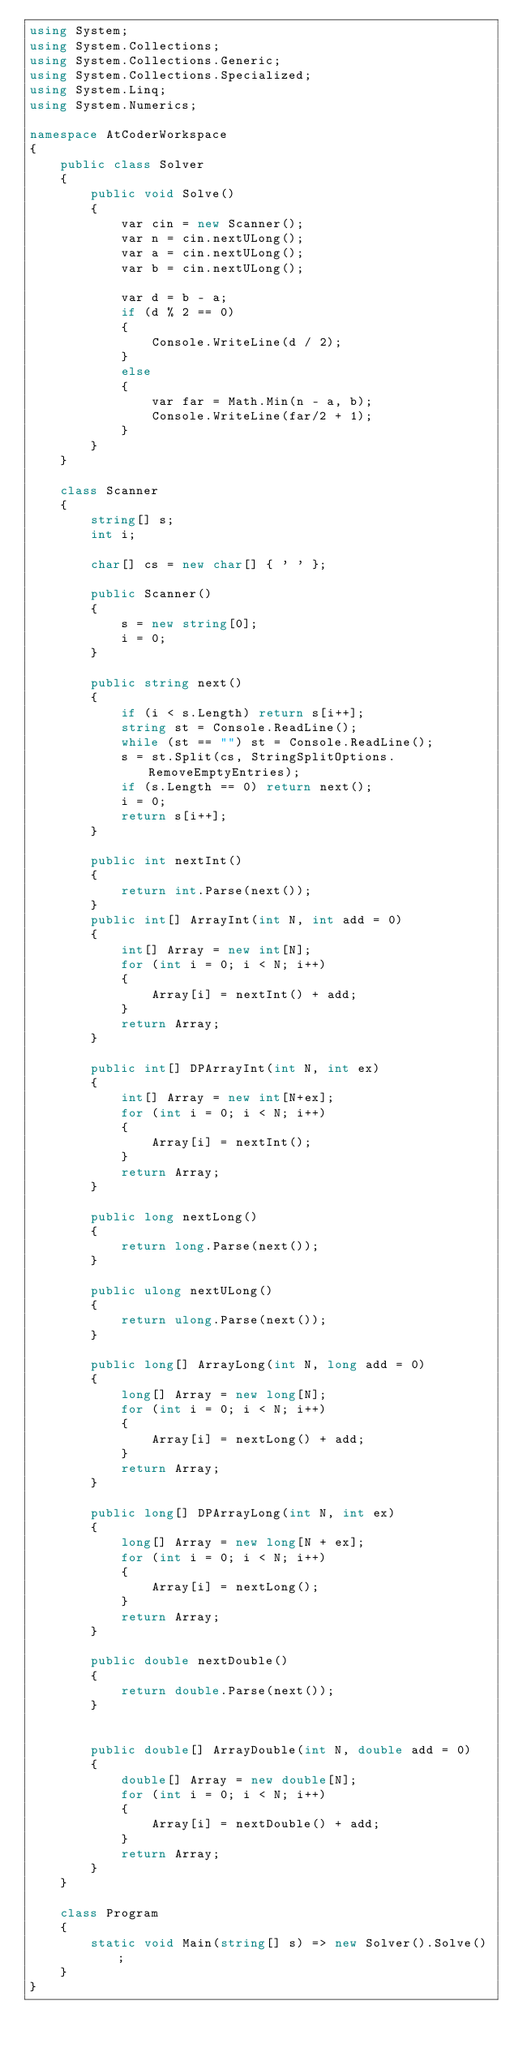Convert code to text. <code><loc_0><loc_0><loc_500><loc_500><_C#_>using System;
using System.Collections;
using System.Collections.Generic;
using System.Collections.Specialized;
using System.Linq;
using System.Numerics;

namespace AtCoderWorkspace
{
    public class Solver
    {
        public void Solve()
        {
            var cin = new Scanner();
            var n = cin.nextULong();
            var a = cin.nextULong();
            var b = cin.nextULong();

            var d = b - a;
            if (d % 2 == 0)
            {
                Console.WriteLine(d / 2);                
            }
            else
            {
                var far = Math.Min(n - a, b);
                Console.WriteLine(far/2 + 1);
            }            
        }
    }

    class Scanner
    {
        string[] s;
        int i;

        char[] cs = new char[] { ' ' };

        public Scanner()
        {
            s = new string[0];
            i = 0;
        }

        public string next()
        {
            if (i < s.Length) return s[i++];
            string st = Console.ReadLine();
            while (st == "") st = Console.ReadLine();
            s = st.Split(cs, StringSplitOptions.RemoveEmptyEntries);
            if (s.Length == 0) return next();
            i = 0;
            return s[i++];
        }

        public int nextInt()
        {
            return int.Parse(next());
        }
        public int[] ArrayInt(int N, int add = 0)
        {
            int[] Array = new int[N];
            for (int i = 0; i < N; i++)
            {
                Array[i] = nextInt() + add;
            }
            return Array;
        }

        public int[] DPArrayInt(int N, int ex)
        {
            int[] Array = new int[N+ex];
            for (int i = 0; i < N; i++)
            {
                Array[i] = nextInt();
            }
            return Array;
        }

        public long nextLong()
        {
            return long.Parse(next());
        }

        public ulong nextULong()
        {
            return ulong.Parse(next());
        }

        public long[] ArrayLong(int N, long add = 0)
        {
            long[] Array = new long[N];
            for (int i = 0; i < N; i++)
            {
                Array[i] = nextLong() + add;
            }
            return Array;
        }

        public long[] DPArrayLong(int N, int ex)
        {
            long[] Array = new long[N + ex];
            for (int i = 0; i < N; i++)
            {
                Array[i] = nextLong();
            }
            return Array;
        }

        public double nextDouble()
        {
            return double.Parse(next());
        }


        public double[] ArrayDouble(int N, double add = 0)
        {
            double[] Array = new double[N];
            for (int i = 0; i < N; i++)
            {
                Array[i] = nextDouble() + add;
            }
            return Array;
        }
    }   

    class Program
    {
        static void Main(string[] s) => new Solver().Solve();
    }
}
</code> 